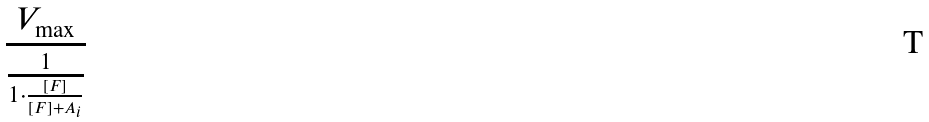Convert formula to latex. <formula><loc_0><loc_0><loc_500><loc_500>\frac { V _ { \max } } { \frac { 1 } { 1 \cdot \frac { [ F ] } { [ F ] + A _ { i } } } }</formula> 